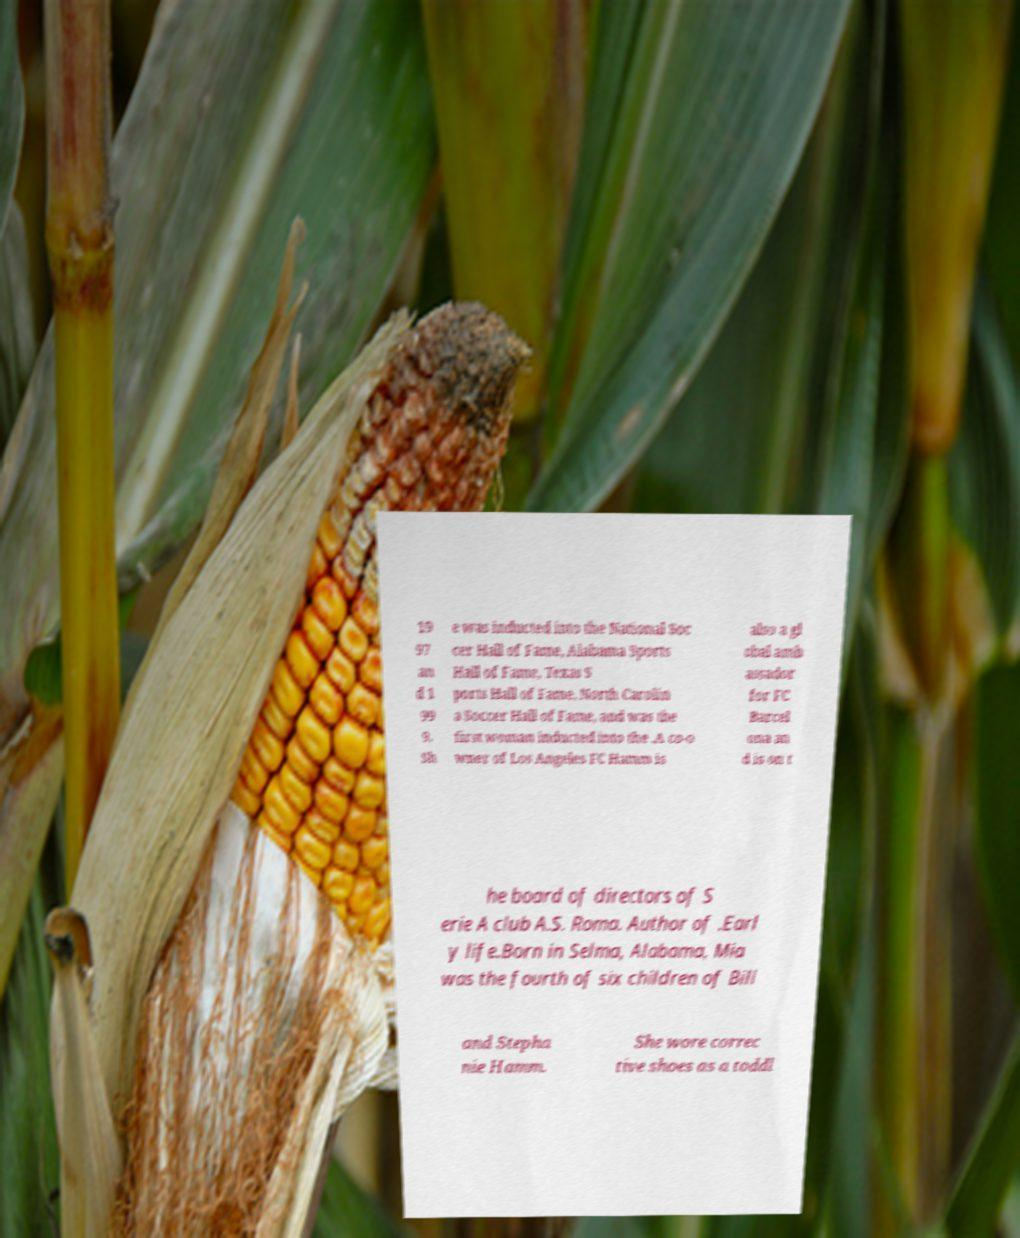Can you read and provide the text displayed in the image?This photo seems to have some interesting text. Can you extract and type it out for me? 19 97 an d 1 99 9. Sh e was inducted into the National Soc cer Hall of Fame, Alabama Sports Hall of Fame, Texas S ports Hall of Fame, North Carolin a Soccer Hall of Fame, and was the first woman inducted into the .A co-o wner of Los Angeles FC Hamm is also a gl obal amb assador for FC Barcel ona an d is on t he board of directors of S erie A club A.S. Roma. Author of .Earl y life.Born in Selma, Alabama, Mia was the fourth of six children of Bill and Stepha nie Hamm. She wore correc tive shoes as a toddl 